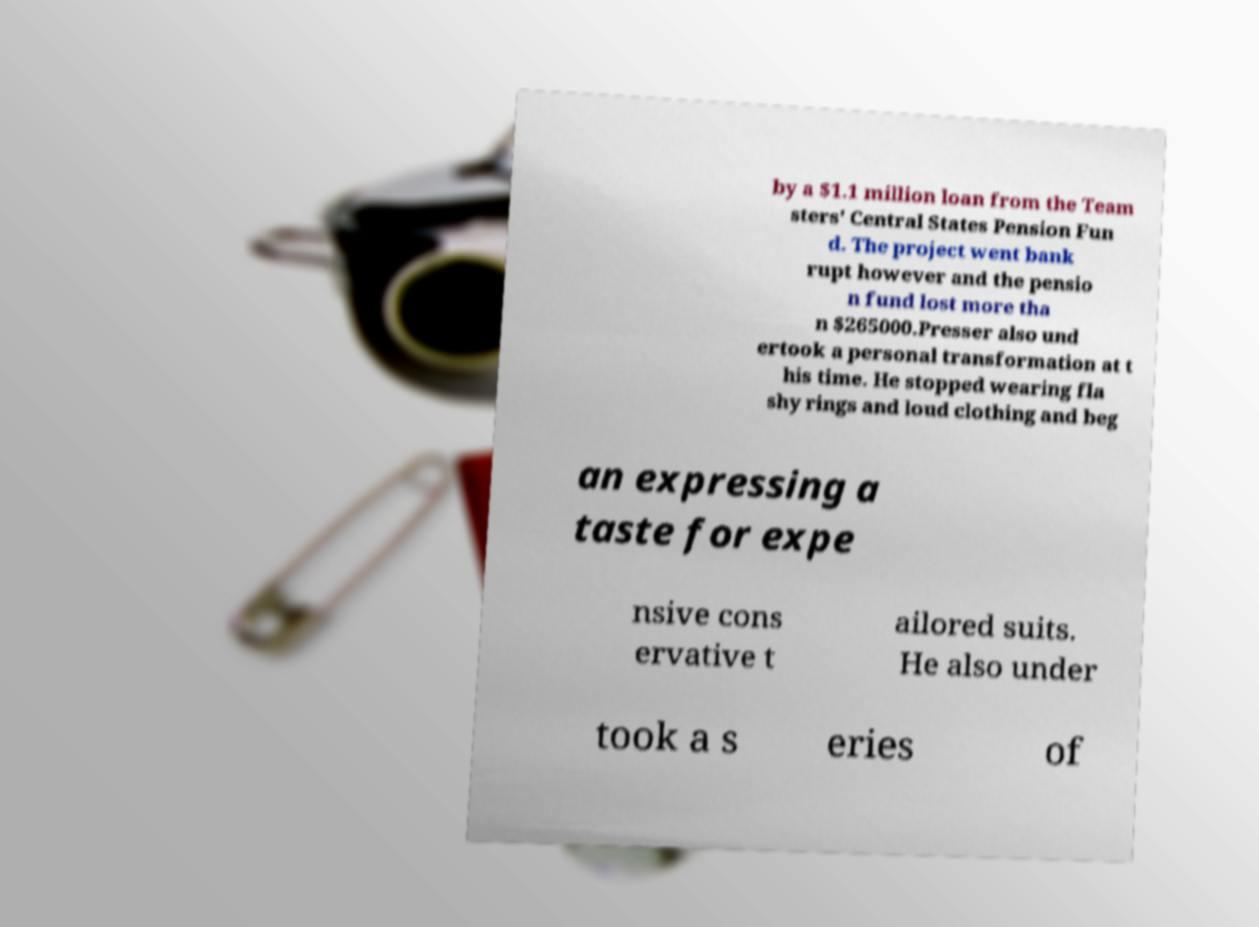Can you read and provide the text displayed in the image?This photo seems to have some interesting text. Can you extract and type it out for me? by a $1.1 million loan from the Team sters' Central States Pension Fun d. The project went bank rupt however and the pensio n fund lost more tha n $265000.Presser also und ertook a personal transformation at t his time. He stopped wearing fla shy rings and loud clothing and beg an expressing a taste for expe nsive cons ervative t ailored suits. He also under took a s eries of 